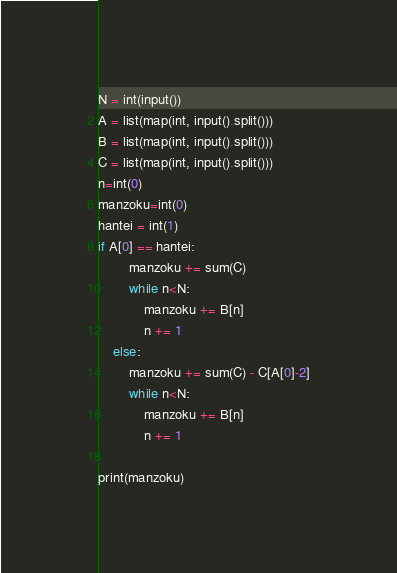Convert code to text. <code><loc_0><loc_0><loc_500><loc_500><_Python_>N = int(input())
A = list(map(int, input().split()))
B = list(map(int, input().split()))
C = list(map(int, input().split()))
n=int(0)
manzoku=int(0)
hantei = int(1)
if A[0] == hantei:
        manzoku += sum(C)
        while n<N:
            manzoku += B[n]
            n += 1
    else:
        manzoku += sum(C) - C[A[0]-2]
        while n<N:
            manzoku += B[n]
            n += 1

print(manzoku)
</code> 